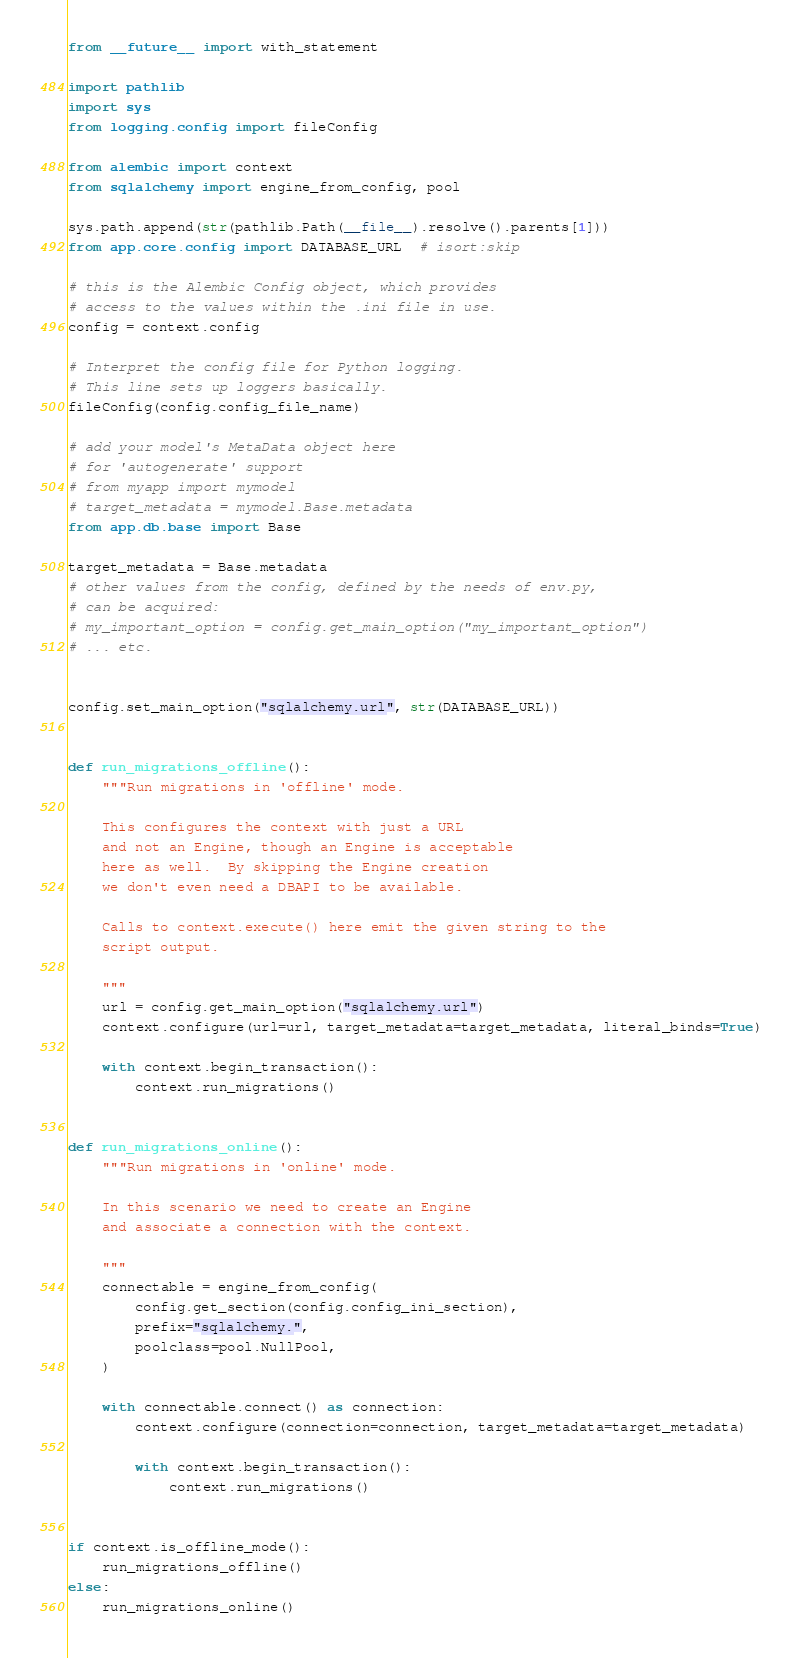Convert code to text. <code><loc_0><loc_0><loc_500><loc_500><_Python_>from __future__ import with_statement

import pathlib
import sys
from logging.config import fileConfig

from alembic import context
from sqlalchemy import engine_from_config, pool

sys.path.append(str(pathlib.Path(__file__).resolve().parents[1]))
from app.core.config import DATABASE_URL  # isort:skip

# this is the Alembic Config object, which provides
# access to the values within the .ini file in use.
config = context.config

# Interpret the config file for Python logging.
# This line sets up loggers basically.
fileConfig(config.config_file_name)

# add your model's MetaData object here
# for 'autogenerate' support
# from myapp import mymodel
# target_metadata = mymodel.Base.metadata
from app.db.base import Base

target_metadata = Base.metadata
# other values from the config, defined by the needs of env.py,
# can be acquired:
# my_important_option = config.get_main_option("my_important_option")
# ... etc.


config.set_main_option("sqlalchemy.url", str(DATABASE_URL))


def run_migrations_offline():
    """Run migrations in 'offline' mode.

    This configures the context with just a URL
    and not an Engine, though an Engine is acceptable
    here as well.  By skipping the Engine creation
    we don't even need a DBAPI to be available.

    Calls to context.execute() here emit the given string to the
    script output.

    """
    url = config.get_main_option("sqlalchemy.url")
    context.configure(url=url, target_metadata=target_metadata, literal_binds=True)

    with context.begin_transaction():
        context.run_migrations()


def run_migrations_online():
    """Run migrations in 'online' mode.

    In this scenario we need to create an Engine
    and associate a connection with the context.

    """
    connectable = engine_from_config(
        config.get_section(config.config_ini_section),
        prefix="sqlalchemy.",
        poolclass=pool.NullPool,
    )

    with connectable.connect() as connection:
        context.configure(connection=connection, target_metadata=target_metadata)

        with context.begin_transaction():
            context.run_migrations()


if context.is_offline_mode():
    run_migrations_offline()
else:
    run_migrations_online()
</code> 